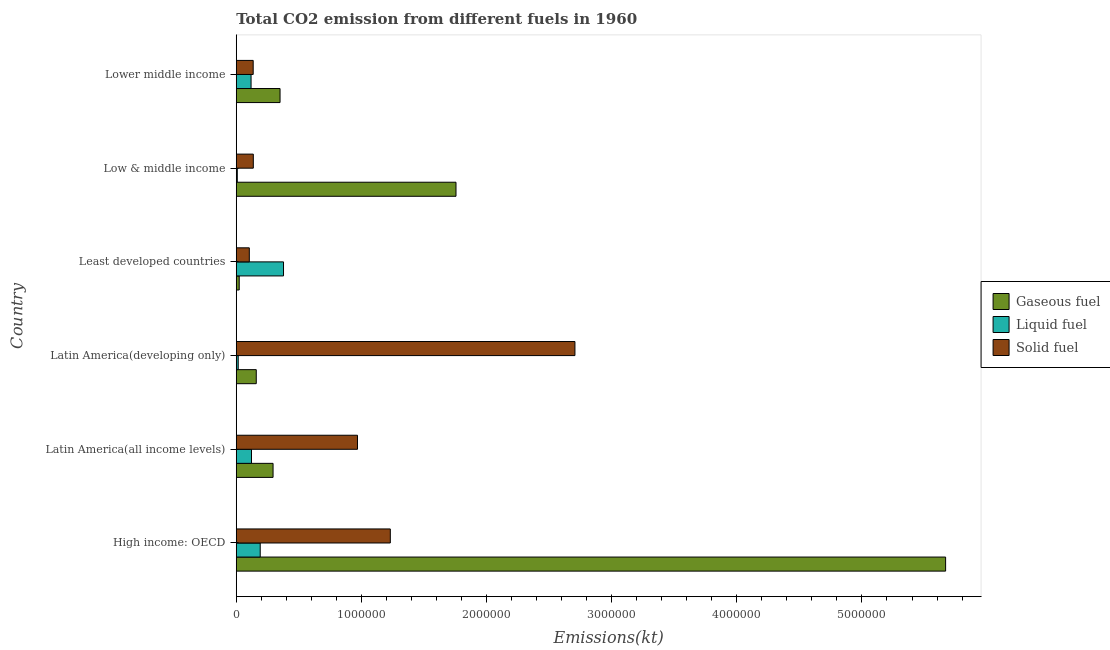How many different coloured bars are there?
Your response must be concise. 3. How many groups of bars are there?
Ensure brevity in your answer.  6. Are the number of bars per tick equal to the number of legend labels?
Provide a succinct answer. Yes. Are the number of bars on each tick of the Y-axis equal?
Your answer should be compact. Yes. What is the label of the 2nd group of bars from the top?
Your answer should be compact. Low & middle income. In how many cases, is the number of bars for a given country not equal to the number of legend labels?
Keep it short and to the point. 0. What is the amount of co2 emissions from gaseous fuel in Latin America(all income levels)?
Your answer should be compact. 2.94e+05. Across all countries, what is the maximum amount of co2 emissions from liquid fuel?
Your answer should be very brief. 3.78e+05. Across all countries, what is the minimum amount of co2 emissions from liquid fuel?
Your response must be concise. 8381.5. In which country was the amount of co2 emissions from liquid fuel maximum?
Provide a succinct answer. Least developed countries. In which country was the amount of co2 emissions from gaseous fuel minimum?
Make the answer very short. Least developed countries. What is the total amount of co2 emissions from solid fuel in the graph?
Give a very brief answer. 5.28e+06. What is the difference between the amount of co2 emissions from liquid fuel in Low & middle income and that in Lower middle income?
Your answer should be compact. -1.10e+05. What is the difference between the amount of co2 emissions from liquid fuel in Low & middle income and the amount of co2 emissions from gaseous fuel in Latin America(developing only)?
Keep it short and to the point. -1.52e+05. What is the average amount of co2 emissions from liquid fuel per country?
Keep it short and to the point. 1.39e+05. What is the difference between the amount of co2 emissions from solid fuel and amount of co2 emissions from gaseous fuel in Lower middle income?
Offer a terse response. -2.15e+05. Is the amount of co2 emissions from liquid fuel in Low & middle income less than that in Lower middle income?
Your response must be concise. Yes. What is the difference between the highest and the second highest amount of co2 emissions from liquid fuel?
Your response must be concise. 1.86e+05. What is the difference between the highest and the lowest amount of co2 emissions from gaseous fuel?
Ensure brevity in your answer.  5.64e+06. What does the 2nd bar from the top in High income: OECD represents?
Provide a short and direct response. Liquid fuel. What does the 2nd bar from the bottom in Low & middle income represents?
Give a very brief answer. Liquid fuel. Are all the bars in the graph horizontal?
Ensure brevity in your answer.  Yes. How many countries are there in the graph?
Make the answer very short. 6. What is the difference between two consecutive major ticks on the X-axis?
Ensure brevity in your answer.  1.00e+06. Are the values on the major ticks of X-axis written in scientific E-notation?
Your response must be concise. No. Does the graph contain any zero values?
Give a very brief answer. No. What is the title of the graph?
Provide a short and direct response. Total CO2 emission from different fuels in 1960. What is the label or title of the X-axis?
Your answer should be very brief. Emissions(kt). What is the label or title of the Y-axis?
Your response must be concise. Country. What is the Emissions(kt) of Gaseous fuel in High income: OECD?
Your response must be concise. 5.67e+06. What is the Emissions(kt) in Liquid fuel in High income: OECD?
Provide a succinct answer. 1.91e+05. What is the Emissions(kt) in Solid fuel in High income: OECD?
Keep it short and to the point. 1.23e+06. What is the Emissions(kt) of Gaseous fuel in Latin America(all income levels)?
Offer a terse response. 2.94e+05. What is the Emissions(kt) in Liquid fuel in Latin America(all income levels)?
Make the answer very short. 1.22e+05. What is the Emissions(kt) of Solid fuel in Latin America(all income levels)?
Your answer should be very brief. 9.69e+05. What is the Emissions(kt) in Gaseous fuel in Latin America(developing only)?
Keep it short and to the point. 1.60e+05. What is the Emissions(kt) of Liquid fuel in Latin America(developing only)?
Your answer should be compact. 1.57e+04. What is the Emissions(kt) in Solid fuel in Latin America(developing only)?
Your response must be concise. 2.71e+06. What is the Emissions(kt) in Gaseous fuel in Least developed countries?
Your answer should be compact. 2.37e+04. What is the Emissions(kt) of Liquid fuel in Least developed countries?
Provide a succinct answer. 3.78e+05. What is the Emissions(kt) of Solid fuel in Least developed countries?
Offer a terse response. 1.04e+05. What is the Emissions(kt) in Gaseous fuel in Low & middle income?
Your response must be concise. 1.76e+06. What is the Emissions(kt) in Liquid fuel in Low & middle income?
Your response must be concise. 8381.5. What is the Emissions(kt) in Solid fuel in Low & middle income?
Ensure brevity in your answer.  1.36e+05. What is the Emissions(kt) of Gaseous fuel in Lower middle income?
Your answer should be compact. 3.50e+05. What is the Emissions(kt) in Liquid fuel in Lower middle income?
Provide a succinct answer. 1.18e+05. What is the Emissions(kt) of Solid fuel in Lower middle income?
Your answer should be compact. 1.35e+05. Across all countries, what is the maximum Emissions(kt) in Gaseous fuel?
Provide a short and direct response. 5.67e+06. Across all countries, what is the maximum Emissions(kt) in Liquid fuel?
Your answer should be very brief. 3.78e+05. Across all countries, what is the maximum Emissions(kt) in Solid fuel?
Your response must be concise. 2.71e+06. Across all countries, what is the minimum Emissions(kt) of Gaseous fuel?
Offer a very short reply. 2.37e+04. Across all countries, what is the minimum Emissions(kt) of Liquid fuel?
Offer a very short reply. 8381.5. Across all countries, what is the minimum Emissions(kt) of Solid fuel?
Give a very brief answer. 1.04e+05. What is the total Emissions(kt) in Gaseous fuel in the graph?
Keep it short and to the point. 8.25e+06. What is the total Emissions(kt) of Liquid fuel in the graph?
Make the answer very short. 8.33e+05. What is the total Emissions(kt) in Solid fuel in the graph?
Your response must be concise. 5.28e+06. What is the difference between the Emissions(kt) of Gaseous fuel in High income: OECD and that in Latin America(all income levels)?
Provide a short and direct response. 5.37e+06. What is the difference between the Emissions(kt) of Liquid fuel in High income: OECD and that in Latin America(all income levels)?
Keep it short and to the point. 6.96e+04. What is the difference between the Emissions(kt) of Solid fuel in High income: OECD and that in Latin America(all income levels)?
Provide a succinct answer. 2.62e+05. What is the difference between the Emissions(kt) of Gaseous fuel in High income: OECD and that in Latin America(developing only)?
Your answer should be very brief. 5.51e+06. What is the difference between the Emissions(kt) of Liquid fuel in High income: OECD and that in Latin America(developing only)?
Give a very brief answer. 1.76e+05. What is the difference between the Emissions(kt) in Solid fuel in High income: OECD and that in Latin America(developing only)?
Make the answer very short. -1.48e+06. What is the difference between the Emissions(kt) of Gaseous fuel in High income: OECD and that in Least developed countries?
Provide a succinct answer. 5.64e+06. What is the difference between the Emissions(kt) of Liquid fuel in High income: OECD and that in Least developed countries?
Ensure brevity in your answer.  -1.86e+05. What is the difference between the Emissions(kt) of Solid fuel in High income: OECD and that in Least developed countries?
Provide a succinct answer. 1.13e+06. What is the difference between the Emissions(kt) in Gaseous fuel in High income: OECD and that in Low & middle income?
Give a very brief answer. 3.91e+06. What is the difference between the Emissions(kt) in Liquid fuel in High income: OECD and that in Low & middle income?
Provide a short and direct response. 1.83e+05. What is the difference between the Emissions(kt) in Solid fuel in High income: OECD and that in Low & middle income?
Your answer should be very brief. 1.09e+06. What is the difference between the Emissions(kt) of Gaseous fuel in High income: OECD and that in Lower middle income?
Your answer should be very brief. 5.32e+06. What is the difference between the Emissions(kt) in Liquid fuel in High income: OECD and that in Lower middle income?
Give a very brief answer. 7.32e+04. What is the difference between the Emissions(kt) in Solid fuel in High income: OECD and that in Lower middle income?
Your answer should be compact. 1.10e+06. What is the difference between the Emissions(kt) in Gaseous fuel in Latin America(all income levels) and that in Latin America(developing only)?
Your answer should be very brief. 1.34e+05. What is the difference between the Emissions(kt) of Liquid fuel in Latin America(all income levels) and that in Latin America(developing only)?
Provide a short and direct response. 1.06e+05. What is the difference between the Emissions(kt) of Solid fuel in Latin America(all income levels) and that in Latin America(developing only)?
Provide a succinct answer. -1.74e+06. What is the difference between the Emissions(kt) in Gaseous fuel in Latin America(all income levels) and that in Least developed countries?
Offer a terse response. 2.70e+05. What is the difference between the Emissions(kt) of Liquid fuel in Latin America(all income levels) and that in Least developed countries?
Your response must be concise. -2.56e+05. What is the difference between the Emissions(kt) of Solid fuel in Latin America(all income levels) and that in Least developed countries?
Provide a succinct answer. 8.65e+05. What is the difference between the Emissions(kt) in Gaseous fuel in Latin America(all income levels) and that in Low & middle income?
Offer a terse response. -1.46e+06. What is the difference between the Emissions(kt) in Liquid fuel in Latin America(all income levels) and that in Low & middle income?
Make the answer very short. 1.14e+05. What is the difference between the Emissions(kt) of Solid fuel in Latin America(all income levels) and that in Low & middle income?
Offer a terse response. 8.33e+05. What is the difference between the Emissions(kt) of Gaseous fuel in Latin America(all income levels) and that in Lower middle income?
Provide a short and direct response. -5.59e+04. What is the difference between the Emissions(kt) of Liquid fuel in Latin America(all income levels) and that in Lower middle income?
Your answer should be compact. 3597.92. What is the difference between the Emissions(kt) of Solid fuel in Latin America(all income levels) and that in Lower middle income?
Keep it short and to the point. 8.33e+05. What is the difference between the Emissions(kt) in Gaseous fuel in Latin America(developing only) and that in Least developed countries?
Your response must be concise. 1.36e+05. What is the difference between the Emissions(kt) in Liquid fuel in Latin America(developing only) and that in Least developed countries?
Your answer should be very brief. -3.62e+05. What is the difference between the Emissions(kt) in Solid fuel in Latin America(developing only) and that in Least developed countries?
Offer a very short reply. 2.60e+06. What is the difference between the Emissions(kt) in Gaseous fuel in Latin America(developing only) and that in Low & middle income?
Keep it short and to the point. -1.60e+06. What is the difference between the Emissions(kt) in Liquid fuel in Latin America(developing only) and that in Low & middle income?
Keep it short and to the point. 7358.18. What is the difference between the Emissions(kt) of Solid fuel in Latin America(developing only) and that in Low & middle income?
Offer a very short reply. 2.57e+06. What is the difference between the Emissions(kt) of Gaseous fuel in Latin America(developing only) and that in Lower middle income?
Keep it short and to the point. -1.90e+05. What is the difference between the Emissions(kt) of Liquid fuel in Latin America(developing only) and that in Lower middle income?
Offer a terse response. -1.03e+05. What is the difference between the Emissions(kt) of Solid fuel in Latin America(developing only) and that in Lower middle income?
Provide a short and direct response. 2.57e+06. What is the difference between the Emissions(kt) of Gaseous fuel in Least developed countries and that in Low & middle income?
Your response must be concise. -1.73e+06. What is the difference between the Emissions(kt) in Liquid fuel in Least developed countries and that in Low & middle income?
Give a very brief answer. 3.69e+05. What is the difference between the Emissions(kt) of Solid fuel in Least developed countries and that in Low & middle income?
Your answer should be very brief. -3.20e+04. What is the difference between the Emissions(kt) in Gaseous fuel in Least developed countries and that in Lower middle income?
Offer a very short reply. -3.26e+05. What is the difference between the Emissions(kt) of Liquid fuel in Least developed countries and that in Lower middle income?
Ensure brevity in your answer.  2.59e+05. What is the difference between the Emissions(kt) in Solid fuel in Least developed countries and that in Lower middle income?
Offer a terse response. -3.10e+04. What is the difference between the Emissions(kt) in Gaseous fuel in Low & middle income and that in Lower middle income?
Make the answer very short. 1.41e+06. What is the difference between the Emissions(kt) of Liquid fuel in Low & middle income and that in Lower middle income?
Your response must be concise. -1.10e+05. What is the difference between the Emissions(kt) in Solid fuel in Low & middle income and that in Lower middle income?
Offer a very short reply. 947.7. What is the difference between the Emissions(kt) in Gaseous fuel in High income: OECD and the Emissions(kt) in Liquid fuel in Latin America(all income levels)?
Make the answer very short. 5.55e+06. What is the difference between the Emissions(kt) in Gaseous fuel in High income: OECD and the Emissions(kt) in Solid fuel in Latin America(all income levels)?
Ensure brevity in your answer.  4.70e+06. What is the difference between the Emissions(kt) of Liquid fuel in High income: OECD and the Emissions(kt) of Solid fuel in Latin America(all income levels)?
Give a very brief answer. -7.77e+05. What is the difference between the Emissions(kt) in Gaseous fuel in High income: OECD and the Emissions(kt) in Liquid fuel in Latin America(developing only)?
Your answer should be compact. 5.65e+06. What is the difference between the Emissions(kt) in Gaseous fuel in High income: OECD and the Emissions(kt) in Solid fuel in Latin America(developing only)?
Your answer should be very brief. 2.96e+06. What is the difference between the Emissions(kt) in Liquid fuel in High income: OECD and the Emissions(kt) in Solid fuel in Latin America(developing only)?
Provide a short and direct response. -2.51e+06. What is the difference between the Emissions(kt) in Gaseous fuel in High income: OECD and the Emissions(kt) in Liquid fuel in Least developed countries?
Your answer should be very brief. 5.29e+06. What is the difference between the Emissions(kt) of Gaseous fuel in High income: OECD and the Emissions(kt) of Solid fuel in Least developed countries?
Your response must be concise. 5.56e+06. What is the difference between the Emissions(kt) of Liquid fuel in High income: OECD and the Emissions(kt) of Solid fuel in Least developed countries?
Provide a short and direct response. 8.72e+04. What is the difference between the Emissions(kt) of Gaseous fuel in High income: OECD and the Emissions(kt) of Liquid fuel in Low & middle income?
Keep it short and to the point. 5.66e+06. What is the difference between the Emissions(kt) of Gaseous fuel in High income: OECD and the Emissions(kt) of Solid fuel in Low & middle income?
Offer a very short reply. 5.53e+06. What is the difference between the Emissions(kt) in Liquid fuel in High income: OECD and the Emissions(kt) in Solid fuel in Low & middle income?
Make the answer very short. 5.52e+04. What is the difference between the Emissions(kt) in Gaseous fuel in High income: OECD and the Emissions(kt) in Liquid fuel in Lower middle income?
Provide a succinct answer. 5.55e+06. What is the difference between the Emissions(kt) of Gaseous fuel in High income: OECD and the Emissions(kt) of Solid fuel in Lower middle income?
Keep it short and to the point. 5.53e+06. What is the difference between the Emissions(kt) in Liquid fuel in High income: OECD and the Emissions(kt) in Solid fuel in Lower middle income?
Offer a very short reply. 5.61e+04. What is the difference between the Emissions(kt) in Gaseous fuel in Latin America(all income levels) and the Emissions(kt) in Liquid fuel in Latin America(developing only)?
Give a very brief answer. 2.78e+05. What is the difference between the Emissions(kt) in Gaseous fuel in Latin America(all income levels) and the Emissions(kt) in Solid fuel in Latin America(developing only)?
Your response must be concise. -2.41e+06. What is the difference between the Emissions(kt) of Liquid fuel in Latin America(all income levels) and the Emissions(kt) of Solid fuel in Latin America(developing only)?
Provide a short and direct response. -2.58e+06. What is the difference between the Emissions(kt) of Gaseous fuel in Latin America(all income levels) and the Emissions(kt) of Liquid fuel in Least developed countries?
Your answer should be compact. -8.36e+04. What is the difference between the Emissions(kt) of Gaseous fuel in Latin America(all income levels) and the Emissions(kt) of Solid fuel in Least developed countries?
Your answer should be very brief. 1.90e+05. What is the difference between the Emissions(kt) in Liquid fuel in Latin America(all income levels) and the Emissions(kt) in Solid fuel in Least developed countries?
Offer a very short reply. 1.76e+04. What is the difference between the Emissions(kt) in Gaseous fuel in Latin America(all income levels) and the Emissions(kt) in Liquid fuel in Low & middle income?
Your response must be concise. 2.86e+05. What is the difference between the Emissions(kt) in Gaseous fuel in Latin America(all income levels) and the Emissions(kt) in Solid fuel in Low & middle income?
Provide a succinct answer. 1.58e+05. What is the difference between the Emissions(kt) in Liquid fuel in Latin America(all income levels) and the Emissions(kt) in Solid fuel in Low & middle income?
Offer a terse response. -1.44e+04. What is the difference between the Emissions(kt) of Gaseous fuel in Latin America(all income levels) and the Emissions(kt) of Liquid fuel in Lower middle income?
Offer a terse response. 1.76e+05. What is the difference between the Emissions(kt) in Gaseous fuel in Latin America(all income levels) and the Emissions(kt) in Solid fuel in Lower middle income?
Offer a very short reply. 1.59e+05. What is the difference between the Emissions(kt) of Liquid fuel in Latin America(all income levels) and the Emissions(kt) of Solid fuel in Lower middle income?
Make the answer very short. -1.34e+04. What is the difference between the Emissions(kt) in Gaseous fuel in Latin America(developing only) and the Emissions(kt) in Liquid fuel in Least developed countries?
Provide a succinct answer. -2.18e+05. What is the difference between the Emissions(kt) of Gaseous fuel in Latin America(developing only) and the Emissions(kt) of Solid fuel in Least developed countries?
Offer a terse response. 5.57e+04. What is the difference between the Emissions(kt) in Liquid fuel in Latin America(developing only) and the Emissions(kt) in Solid fuel in Least developed countries?
Keep it short and to the point. -8.86e+04. What is the difference between the Emissions(kt) in Gaseous fuel in Latin America(developing only) and the Emissions(kt) in Liquid fuel in Low & middle income?
Your response must be concise. 1.52e+05. What is the difference between the Emissions(kt) of Gaseous fuel in Latin America(developing only) and the Emissions(kt) of Solid fuel in Low & middle income?
Ensure brevity in your answer.  2.37e+04. What is the difference between the Emissions(kt) of Liquid fuel in Latin America(developing only) and the Emissions(kt) of Solid fuel in Low & middle income?
Your answer should be very brief. -1.21e+05. What is the difference between the Emissions(kt) in Gaseous fuel in Latin America(developing only) and the Emissions(kt) in Liquid fuel in Lower middle income?
Provide a succinct answer. 4.17e+04. What is the difference between the Emissions(kt) in Gaseous fuel in Latin America(developing only) and the Emissions(kt) in Solid fuel in Lower middle income?
Provide a succinct answer. 2.47e+04. What is the difference between the Emissions(kt) in Liquid fuel in Latin America(developing only) and the Emissions(kt) in Solid fuel in Lower middle income?
Offer a terse response. -1.20e+05. What is the difference between the Emissions(kt) of Gaseous fuel in Least developed countries and the Emissions(kt) of Liquid fuel in Low & middle income?
Your answer should be compact. 1.53e+04. What is the difference between the Emissions(kt) in Gaseous fuel in Least developed countries and the Emissions(kt) in Solid fuel in Low & middle income?
Provide a short and direct response. -1.13e+05. What is the difference between the Emissions(kt) of Liquid fuel in Least developed countries and the Emissions(kt) of Solid fuel in Low & middle income?
Ensure brevity in your answer.  2.41e+05. What is the difference between the Emissions(kt) of Gaseous fuel in Least developed countries and the Emissions(kt) of Liquid fuel in Lower middle income?
Your answer should be very brief. -9.46e+04. What is the difference between the Emissions(kt) in Gaseous fuel in Least developed countries and the Emissions(kt) in Solid fuel in Lower middle income?
Offer a very short reply. -1.12e+05. What is the difference between the Emissions(kt) of Liquid fuel in Least developed countries and the Emissions(kt) of Solid fuel in Lower middle income?
Provide a succinct answer. 2.42e+05. What is the difference between the Emissions(kt) of Gaseous fuel in Low & middle income and the Emissions(kt) of Liquid fuel in Lower middle income?
Offer a terse response. 1.64e+06. What is the difference between the Emissions(kt) of Gaseous fuel in Low & middle income and the Emissions(kt) of Solid fuel in Lower middle income?
Your answer should be compact. 1.62e+06. What is the difference between the Emissions(kt) in Liquid fuel in Low & middle income and the Emissions(kt) in Solid fuel in Lower middle income?
Keep it short and to the point. -1.27e+05. What is the average Emissions(kt) in Gaseous fuel per country?
Your response must be concise. 1.38e+06. What is the average Emissions(kt) in Liquid fuel per country?
Your answer should be compact. 1.39e+05. What is the average Emissions(kt) in Solid fuel per country?
Provide a succinct answer. 8.80e+05. What is the difference between the Emissions(kt) of Gaseous fuel and Emissions(kt) of Liquid fuel in High income: OECD?
Provide a short and direct response. 5.48e+06. What is the difference between the Emissions(kt) of Gaseous fuel and Emissions(kt) of Solid fuel in High income: OECD?
Your response must be concise. 4.44e+06. What is the difference between the Emissions(kt) in Liquid fuel and Emissions(kt) in Solid fuel in High income: OECD?
Provide a succinct answer. -1.04e+06. What is the difference between the Emissions(kt) in Gaseous fuel and Emissions(kt) in Liquid fuel in Latin America(all income levels)?
Offer a terse response. 1.72e+05. What is the difference between the Emissions(kt) in Gaseous fuel and Emissions(kt) in Solid fuel in Latin America(all income levels)?
Your answer should be very brief. -6.75e+05. What is the difference between the Emissions(kt) in Liquid fuel and Emissions(kt) in Solid fuel in Latin America(all income levels)?
Provide a succinct answer. -8.47e+05. What is the difference between the Emissions(kt) of Gaseous fuel and Emissions(kt) of Liquid fuel in Latin America(developing only)?
Offer a terse response. 1.44e+05. What is the difference between the Emissions(kt) in Gaseous fuel and Emissions(kt) in Solid fuel in Latin America(developing only)?
Offer a very short reply. -2.55e+06. What is the difference between the Emissions(kt) in Liquid fuel and Emissions(kt) in Solid fuel in Latin America(developing only)?
Keep it short and to the point. -2.69e+06. What is the difference between the Emissions(kt) in Gaseous fuel and Emissions(kt) in Liquid fuel in Least developed countries?
Keep it short and to the point. -3.54e+05. What is the difference between the Emissions(kt) of Gaseous fuel and Emissions(kt) of Solid fuel in Least developed countries?
Provide a succinct answer. -8.06e+04. What is the difference between the Emissions(kt) of Liquid fuel and Emissions(kt) of Solid fuel in Least developed countries?
Give a very brief answer. 2.73e+05. What is the difference between the Emissions(kt) of Gaseous fuel and Emissions(kt) of Liquid fuel in Low & middle income?
Offer a terse response. 1.75e+06. What is the difference between the Emissions(kt) in Gaseous fuel and Emissions(kt) in Solid fuel in Low & middle income?
Your answer should be very brief. 1.62e+06. What is the difference between the Emissions(kt) of Liquid fuel and Emissions(kt) of Solid fuel in Low & middle income?
Give a very brief answer. -1.28e+05. What is the difference between the Emissions(kt) in Gaseous fuel and Emissions(kt) in Liquid fuel in Lower middle income?
Keep it short and to the point. 2.32e+05. What is the difference between the Emissions(kt) of Gaseous fuel and Emissions(kt) of Solid fuel in Lower middle income?
Your answer should be very brief. 2.15e+05. What is the difference between the Emissions(kt) in Liquid fuel and Emissions(kt) in Solid fuel in Lower middle income?
Provide a succinct answer. -1.70e+04. What is the ratio of the Emissions(kt) of Gaseous fuel in High income: OECD to that in Latin America(all income levels)?
Offer a terse response. 19.27. What is the ratio of the Emissions(kt) of Liquid fuel in High income: OECD to that in Latin America(all income levels)?
Offer a terse response. 1.57. What is the ratio of the Emissions(kt) of Solid fuel in High income: OECD to that in Latin America(all income levels)?
Your answer should be very brief. 1.27. What is the ratio of the Emissions(kt) in Gaseous fuel in High income: OECD to that in Latin America(developing only)?
Provide a short and direct response. 35.43. What is the ratio of the Emissions(kt) of Liquid fuel in High income: OECD to that in Latin America(developing only)?
Keep it short and to the point. 12.16. What is the ratio of the Emissions(kt) in Solid fuel in High income: OECD to that in Latin America(developing only)?
Provide a succinct answer. 0.45. What is the ratio of the Emissions(kt) in Gaseous fuel in High income: OECD to that in Least developed countries?
Your answer should be very brief. 239.17. What is the ratio of the Emissions(kt) of Liquid fuel in High income: OECD to that in Least developed countries?
Provide a succinct answer. 0.51. What is the ratio of the Emissions(kt) of Solid fuel in High income: OECD to that in Least developed countries?
Provide a short and direct response. 11.8. What is the ratio of the Emissions(kt) of Gaseous fuel in High income: OECD to that in Low & middle income?
Your answer should be compact. 3.23. What is the ratio of the Emissions(kt) of Liquid fuel in High income: OECD to that in Low & middle income?
Keep it short and to the point. 22.84. What is the ratio of the Emissions(kt) in Solid fuel in High income: OECD to that in Low & middle income?
Your response must be concise. 9.04. What is the ratio of the Emissions(kt) in Gaseous fuel in High income: OECD to that in Lower middle income?
Provide a succinct answer. 16.2. What is the ratio of the Emissions(kt) of Liquid fuel in High income: OECD to that in Lower middle income?
Give a very brief answer. 1.62. What is the ratio of the Emissions(kt) in Solid fuel in High income: OECD to that in Lower middle income?
Your response must be concise. 9.1. What is the ratio of the Emissions(kt) in Gaseous fuel in Latin America(all income levels) to that in Latin America(developing only)?
Offer a terse response. 1.84. What is the ratio of the Emissions(kt) of Liquid fuel in Latin America(all income levels) to that in Latin America(developing only)?
Your answer should be compact. 7.74. What is the ratio of the Emissions(kt) in Solid fuel in Latin America(all income levels) to that in Latin America(developing only)?
Make the answer very short. 0.36. What is the ratio of the Emissions(kt) of Gaseous fuel in Latin America(all income levels) to that in Least developed countries?
Give a very brief answer. 12.41. What is the ratio of the Emissions(kt) in Liquid fuel in Latin America(all income levels) to that in Least developed countries?
Offer a terse response. 0.32. What is the ratio of the Emissions(kt) of Solid fuel in Latin America(all income levels) to that in Least developed countries?
Keep it short and to the point. 9.29. What is the ratio of the Emissions(kt) of Gaseous fuel in Latin America(all income levels) to that in Low & middle income?
Give a very brief answer. 0.17. What is the ratio of the Emissions(kt) in Liquid fuel in Latin America(all income levels) to that in Low & middle income?
Your response must be concise. 14.54. What is the ratio of the Emissions(kt) in Solid fuel in Latin America(all income levels) to that in Low & middle income?
Provide a succinct answer. 7.11. What is the ratio of the Emissions(kt) in Gaseous fuel in Latin America(all income levels) to that in Lower middle income?
Give a very brief answer. 0.84. What is the ratio of the Emissions(kt) of Liquid fuel in Latin America(all income levels) to that in Lower middle income?
Give a very brief answer. 1.03. What is the ratio of the Emissions(kt) in Solid fuel in Latin America(all income levels) to that in Lower middle income?
Make the answer very short. 7.16. What is the ratio of the Emissions(kt) in Gaseous fuel in Latin America(developing only) to that in Least developed countries?
Give a very brief answer. 6.75. What is the ratio of the Emissions(kt) of Liquid fuel in Latin America(developing only) to that in Least developed countries?
Offer a very short reply. 0.04. What is the ratio of the Emissions(kt) of Solid fuel in Latin America(developing only) to that in Least developed countries?
Ensure brevity in your answer.  25.95. What is the ratio of the Emissions(kt) in Gaseous fuel in Latin America(developing only) to that in Low & middle income?
Give a very brief answer. 0.09. What is the ratio of the Emissions(kt) of Liquid fuel in Latin America(developing only) to that in Low & middle income?
Provide a succinct answer. 1.88. What is the ratio of the Emissions(kt) in Solid fuel in Latin America(developing only) to that in Low & middle income?
Give a very brief answer. 19.86. What is the ratio of the Emissions(kt) of Gaseous fuel in Latin America(developing only) to that in Lower middle income?
Provide a short and direct response. 0.46. What is the ratio of the Emissions(kt) in Liquid fuel in Latin America(developing only) to that in Lower middle income?
Offer a very short reply. 0.13. What is the ratio of the Emissions(kt) of Solid fuel in Latin America(developing only) to that in Lower middle income?
Your response must be concise. 20. What is the ratio of the Emissions(kt) of Gaseous fuel in Least developed countries to that in Low & middle income?
Make the answer very short. 0.01. What is the ratio of the Emissions(kt) in Liquid fuel in Least developed countries to that in Low & middle income?
Your answer should be very brief. 45.06. What is the ratio of the Emissions(kt) of Solid fuel in Least developed countries to that in Low & middle income?
Ensure brevity in your answer.  0.77. What is the ratio of the Emissions(kt) in Gaseous fuel in Least developed countries to that in Lower middle income?
Give a very brief answer. 0.07. What is the ratio of the Emissions(kt) of Liquid fuel in Least developed countries to that in Lower middle income?
Your response must be concise. 3.19. What is the ratio of the Emissions(kt) of Solid fuel in Least developed countries to that in Lower middle income?
Your answer should be very brief. 0.77. What is the ratio of the Emissions(kt) in Gaseous fuel in Low & middle income to that in Lower middle income?
Your response must be concise. 5.02. What is the ratio of the Emissions(kt) of Liquid fuel in Low & middle income to that in Lower middle income?
Give a very brief answer. 0.07. What is the ratio of the Emissions(kt) in Solid fuel in Low & middle income to that in Lower middle income?
Give a very brief answer. 1.01. What is the difference between the highest and the second highest Emissions(kt) in Gaseous fuel?
Offer a terse response. 3.91e+06. What is the difference between the highest and the second highest Emissions(kt) of Liquid fuel?
Make the answer very short. 1.86e+05. What is the difference between the highest and the second highest Emissions(kt) in Solid fuel?
Ensure brevity in your answer.  1.48e+06. What is the difference between the highest and the lowest Emissions(kt) of Gaseous fuel?
Ensure brevity in your answer.  5.64e+06. What is the difference between the highest and the lowest Emissions(kt) of Liquid fuel?
Make the answer very short. 3.69e+05. What is the difference between the highest and the lowest Emissions(kt) in Solid fuel?
Provide a short and direct response. 2.60e+06. 